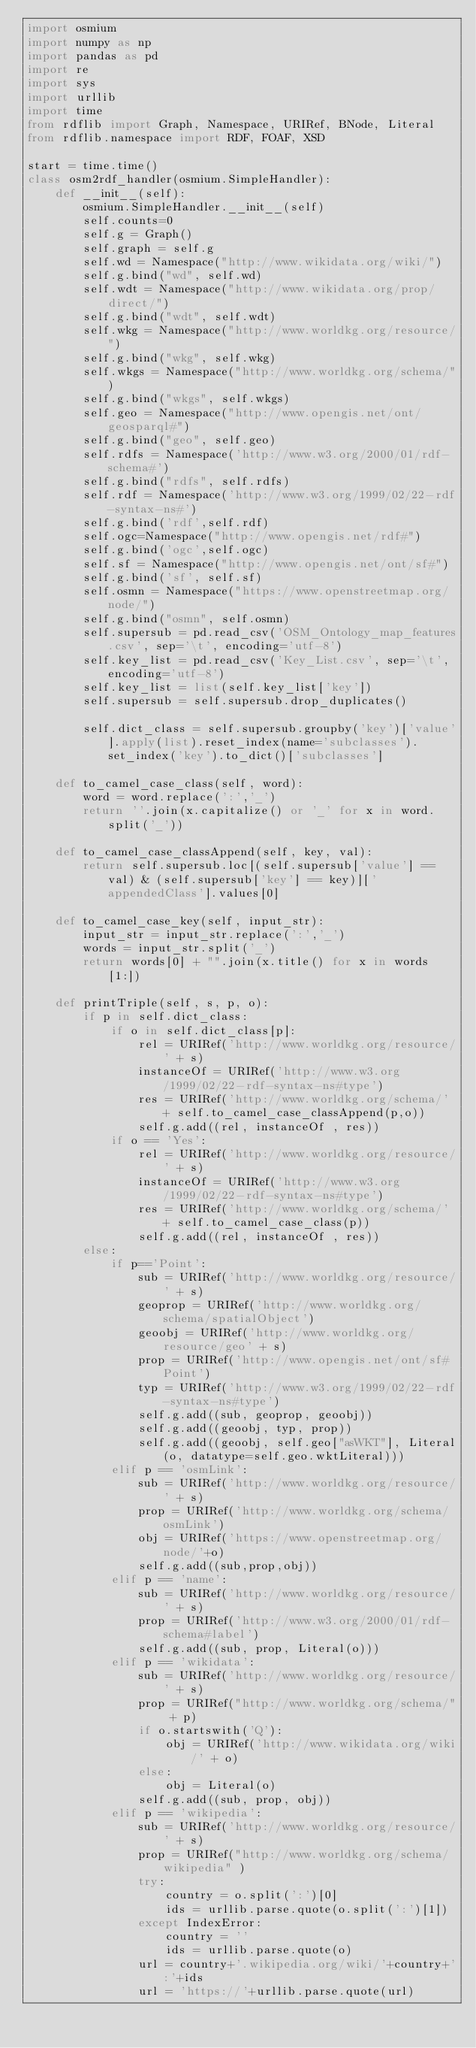Convert code to text. <code><loc_0><loc_0><loc_500><loc_500><_Python_>import osmium
import numpy as np
import pandas as pd
import re
import sys
import urllib
import time
from rdflib import Graph, Namespace, URIRef, BNode, Literal
from rdflib.namespace import RDF, FOAF, XSD

start = time.time()
class osm2rdf_handler(osmium.SimpleHandler):
    def __init__(self):
        osmium.SimpleHandler.__init__(self)    
        self.counts=0
        self.g = Graph()
        self.graph = self.g
        self.wd = Namespace("http://www.wikidata.org/wiki/")
        self.g.bind("wd", self.wd)
        self.wdt = Namespace("http://www.wikidata.org/prop/direct/")
        self.g.bind("wdt", self.wdt)
        self.wkg = Namespace("http://www.worldkg.org/resource/")
        self.g.bind("wkg", self.wkg)
        self.wkgs = Namespace("http://www.worldkg.org/schema/")
        self.g.bind("wkgs", self.wkgs)
        self.geo = Namespace("http://www.opengis.net/ont/geosparql#")
        self.g.bind("geo", self.geo)
        self.rdfs = Namespace('http://www.w3.org/2000/01/rdf-schema#')
        self.g.bind("rdfs", self.rdfs)
        self.rdf = Namespace('http://www.w3.org/1999/02/22-rdf-syntax-ns#')
        self.g.bind('rdf',self.rdf)
        self.ogc=Namespace("http://www.opengis.net/rdf#")
        self.g.bind('ogc',self.ogc)
        self.sf = Namespace("http://www.opengis.net/ont/sf#")
        self.g.bind('sf', self.sf)
        self.osmn = Namespace("https://www.openstreetmap.org/node/")
        self.g.bind("osmn", self.osmn)
        self.supersub = pd.read_csv('OSM_Ontology_map_features.csv', sep='\t', encoding='utf-8')
        self.key_list = pd.read_csv('Key_List.csv', sep='\t', encoding='utf-8')
        self.key_list = list(self.key_list['key'])
        self.supersub = self.supersub.drop_duplicates()
        
        self.dict_class = self.supersub.groupby('key')['value'].apply(list).reset_index(name='subclasses').set_index('key').to_dict()['subclasses']
    
    def to_camel_case_class(self, word):
        word = word.replace(':','_')
        return ''.join(x.capitalize() or '_' for x in word.split('_'))
    
    def to_camel_case_classAppend(self, key, val):
        return self.supersub.loc[(self.supersub['value'] == val) & (self.supersub['key'] == key)]['appendedClass'].values[0]
    
    def to_camel_case_key(self, input_str):
        input_str = input_str.replace(':','_')
        words = input_str.split('_')
        return words[0] + "".join(x.title() for x in words[1:])
    
    def printTriple(self, s, p, o):
        if p in self.dict_class: 
            if o in self.dict_class[p]:
                rel = URIRef('http://www.worldkg.org/resource/' + s)
                instanceOf = URIRef('http://www.w3.org/1999/02/22-rdf-syntax-ns#type')
                res = URIRef('http://www.worldkg.org/schema/' + self.to_camel_case_classAppend(p,o))
                self.g.add((rel, instanceOf , res))
            if o == 'Yes':
                rel = URIRef('http://www.worldkg.org/resource/' + s)
                instanceOf = URIRef('http://www.w3.org/1999/02/22-rdf-syntax-ns#type')
                res = URIRef('http://www.worldkg.org/schema/' + self.to_camel_case_class(p))
                self.g.add((rel, instanceOf , res))
        else:
            if p=='Point':
                sub = URIRef('http://www.worldkg.org/resource/' + s)
                geoprop = URIRef('http://www.worldkg.org/schema/spatialObject')
                geoobj = URIRef('http://www.worldkg.org/resource/geo' + s)
                prop = URIRef('http://www.opengis.net/ont/sf#Point')
                typ = URIRef('http://www.w3.org/1999/02/22-rdf-syntax-ns#type')
                self.g.add((sub, geoprop, geoobj))
                self.g.add((geoobj, typ, prop))
                self.g.add((geoobj, self.geo["asWKT"], Literal(o, datatype=self.geo.wktLiteral)))
            elif p == 'osmLink':
                sub = URIRef('http://www.worldkg.org/resource/' + s)
                prop = URIRef('http://www.worldkg.org/schema/osmLink')
                obj = URIRef('https://www.openstreetmap.org/node/'+o)
                self.g.add((sub,prop,obj))
            elif p == 'name':
                sub = URIRef('http://www.worldkg.org/resource/' + s)
                prop = URIRef('http://www.w3.org/2000/01/rdf-schema#label')
                self.g.add((sub, prop, Literal(o)))
            elif p == 'wikidata':
                sub = URIRef('http://www.worldkg.org/resource/' + s)
                prop = URIRef("http://www.worldkg.org/schema/" + p)
                if o.startswith('Q'):
                    obj = URIRef('http://www.wikidata.org/wiki/' + o)
                else:
                    obj = Literal(o)
                self.g.add((sub, prop, obj))
            elif p == 'wikipedia':
                sub = URIRef('http://www.worldkg.org/resource/' + s)
                prop = URIRef("http://www.worldkg.org/schema/wikipedia" )
                try:
                    country = o.split(':')[0]
                    ids = urllib.parse.quote(o.split(':')[1])
                except IndexError:
                    country = ''
                    ids = urllib.parse.quote(o)
                url = country+'.wikipedia.org/wiki/'+country+':'+ids
                url = 'https://'+urllib.parse.quote(url)</code> 